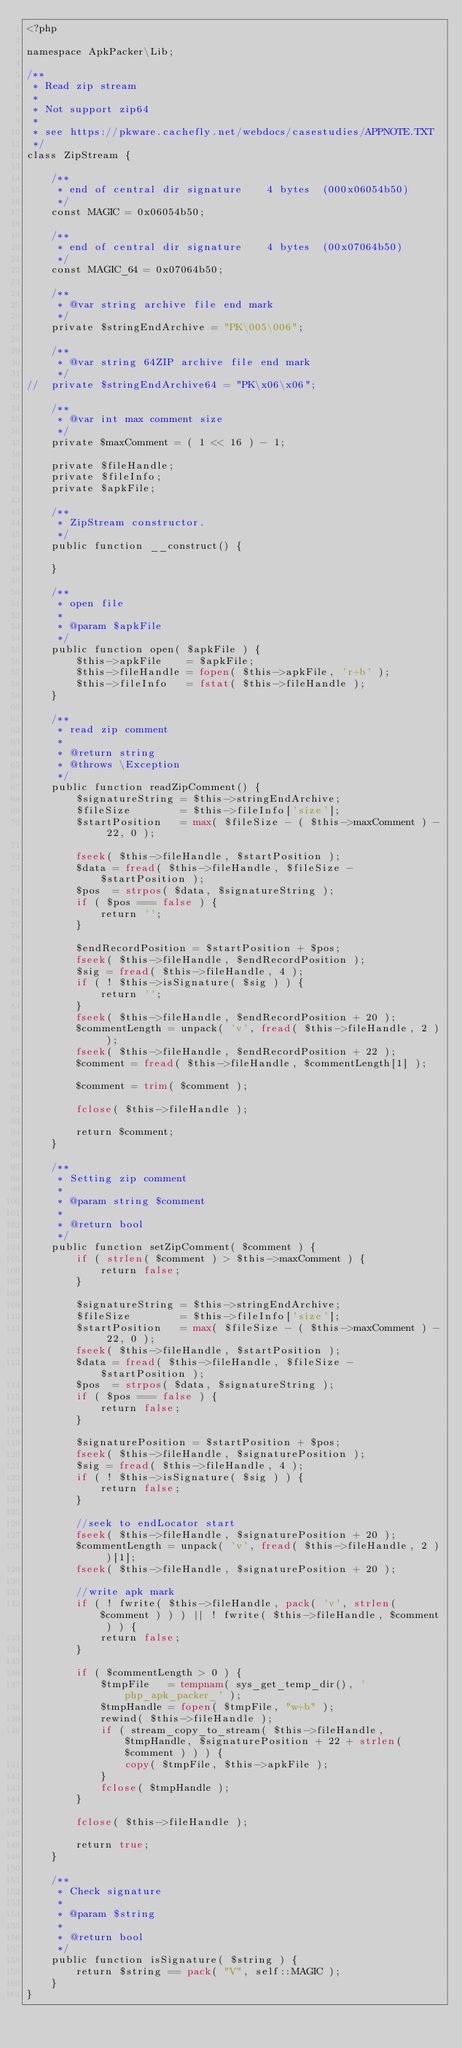<code> <loc_0><loc_0><loc_500><loc_500><_PHP_><?php

namespace ApkPacker\Lib;

/**
 * Read zip stream
 *
 * Not support zip64
 *
 * see https://pkware.cachefly.net/webdocs/casestudies/APPNOTE.TXT
 */
class ZipStream {

	/**
	 * end of central dir signature    4 bytes  (000x06054b50)
	 */
	const MAGIC = 0x06054b50;

	/**
	 * end of central dir signature    4 bytes  (00x07064b50)
	 */
	const MAGIC_64 = 0x07064b50;

	/**
	 * @var string archive file end mark
	 */
	private $stringEndArchive = "PK\005\006";

	/**
	 * @var string 64ZIP archive file end mark
	 */
//	private $stringEndArchive64 = "PK\x06\x06";

	/**
	 * @var int max comment size
	 */
	private $maxComment = ( 1 << 16 ) - 1;

	private $fileHandle;
	private $fileInfo;
	private $apkFile;

	/**
	 * ZipStream constructor.
	 */
	public function __construct() {

	}

	/**
	 * open file
	 *
	 * @param $apkFile
	 */
	public function open( $apkFile ) {
		$this->apkFile    = $apkFile;
		$this->fileHandle = fopen( $this->apkFile, 'r+b' );
		$this->fileInfo   = fstat( $this->fileHandle );
	}

	/**
	 * read zip comment
	 *
	 * @return string
	 * @throws \Exception
	 */
	public function readZipComment() {
		$signatureString = $this->stringEndArchive;
		$fileSize        = $this->fileInfo['size'];
		$startPosition   = max( $fileSize - ( $this->maxComment ) - 22, 0 );

		fseek( $this->fileHandle, $startPosition );
		$data = fread( $this->fileHandle, $fileSize - $startPosition );
		$pos  = strpos( $data, $signatureString );
		if ( $pos === false ) {
			return '';
		}

		$endRecordPosition = $startPosition + $pos;
		fseek( $this->fileHandle, $endRecordPosition );
		$sig = fread( $this->fileHandle, 4 );
		if ( ! $this->isSignature( $sig ) ) {
			return '';
		}
		fseek( $this->fileHandle, $endRecordPosition + 20 );
		$commentLength = unpack( 'v', fread( $this->fileHandle, 2 ) );
		fseek( $this->fileHandle, $endRecordPosition + 22 );
		$comment = fread( $this->fileHandle, $commentLength[1] );

		$comment = trim( $comment );

		fclose( $this->fileHandle );

		return $comment;
	}

	/**
	 * Setting zip comment
	 *
	 * @param string $comment
	 *
	 * @return bool
	 */
	public function setZipComment( $comment ) {
		if ( strlen( $comment ) > $this->maxComment ) {
			return false;
		}

		$signatureString = $this->stringEndArchive;
		$fileSize        = $this->fileInfo['size'];
		$startPosition   = max( $fileSize - ( $this->maxComment ) - 22, 0 );
		fseek( $this->fileHandle, $startPosition );
		$data = fread( $this->fileHandle, $fileSize - $startPosition );
		$pos  = strpos( $data, $signatureString );
		if ( $pos === false ) {
			return false;
		}

		$signaturePosition = $startPosition + $pos;
		fseek( $this->fileHandle, $signaturePosition );
		$sig = fread( $this->fileHandle, 4 );
		if ( ! $this->isSignature( $sig ) ) {
			return false;
		}

		//seek to endLocator start
		fseek( $this->fileHandle, $signaturePosition + 20 );
		$commentLength = unpack( 'v', fread( $this->fileHandle, 2 ) )[1];
		fseek( $this->fileHandle, $signaturePosition + 20 );

		//write apk mark
		if ( ! fwrite( $this->fileHandle, pack( 'v', strlen( $comment ) ) ) || ! fwrite( $this->fileHandle, $comment ) ) {
			return false;
		}

		if ( $commentLength > 0 ) {
			$tmpFile   = tempnam( sys_get_temp_dir(), 'php_apk_packer_' );
			$tmpHandle = fopen( $tmpFile, "w+b" );
			rewind( $this->fileHandle );
			if ( stream_copy_to_stream( $this->fileHandle, $tmpHandle, $signaturePosition + 22 + strlen( $comment ) ) ) {
				copy( $tmpFile, $this->apkFile );
			}
			fclose( $tmpHandle );
		}

		fclose( $this->fileHandle );

		return true;
	}

	/**
	 * Check signature
	 *
	 * @param $string
	 *
	 * @return bool
	 */
	public function isSignature( $string ) {
		return $string == pack( "V", self::MAGIC );
	}
}</code> 